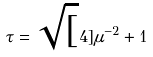Convert formula to latex. <formula><loc_0><loc_0><loc_500><loc_500>\tau = \sqrt { [ } 4 ] { \mu ^ { - 2 } + 1 }</formula> 